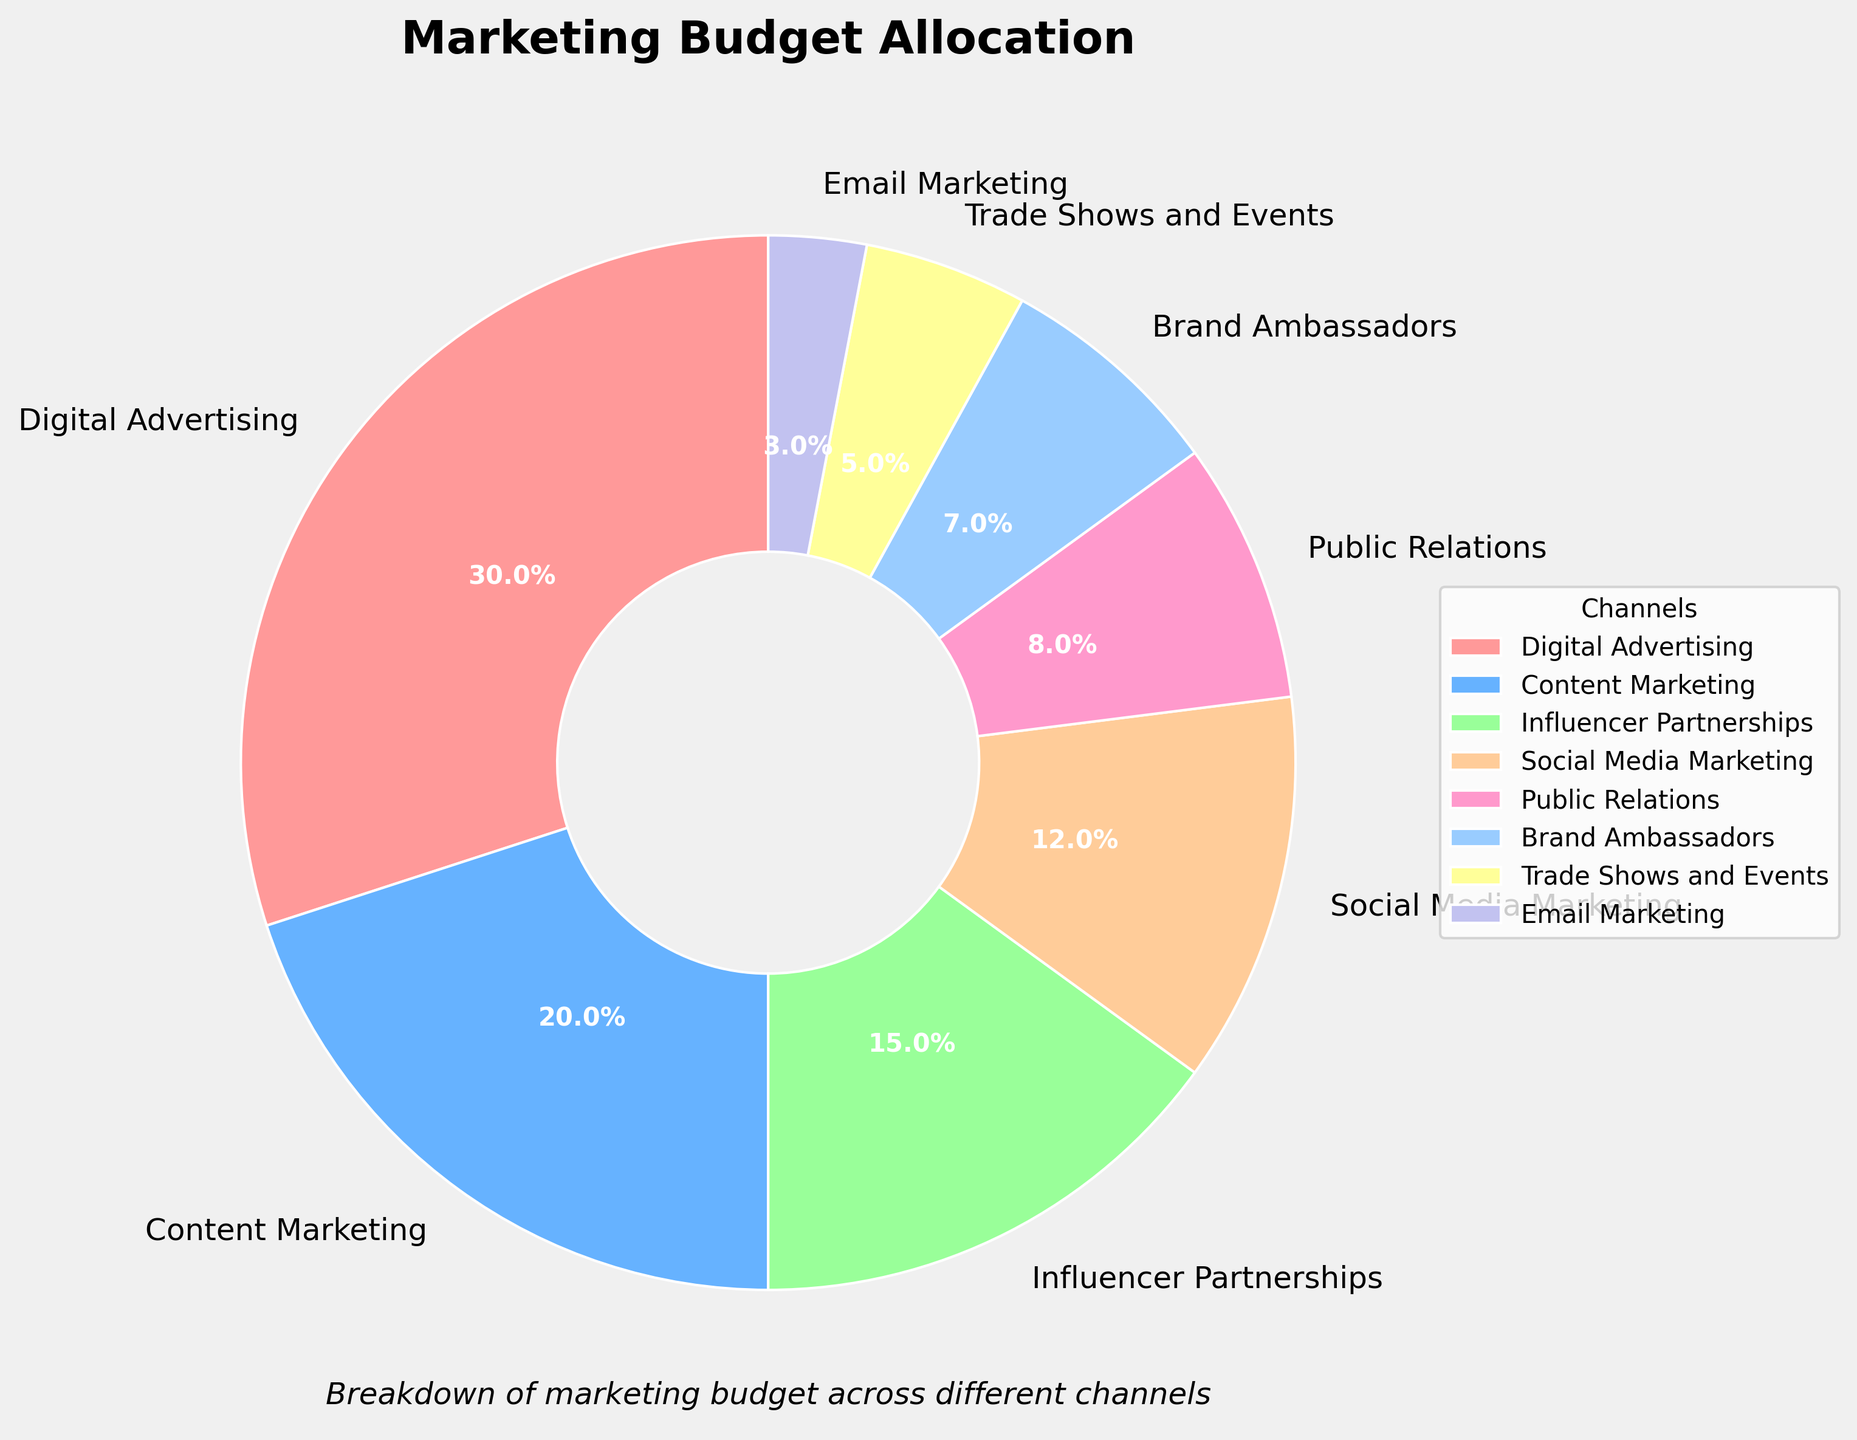What percentage of the budget is allocated to both Digital Advertising and Content Marketing combined? First, find the percentage of the budget for Digital Advertising (30%) and Content Marketing (20%). Then, add these two percentages together: 30% + 20% = 50%
Answer: 50% How much more of the budget is spent on Social Media Marketing compared to Email Marketing? Find the percentage for Social Media Marketing (12%) and Email Marketing (3%). Subtract the percentage for Email Marketing from Social Media Marketing: 12% - 3% = 9%
Answer: 9% Which marketing channel has the highest allocation? Look at the pie chart and identify the channel with the largest section. Digital Advertising, with 30%, is the largest.
Answer: Digital Advertising Is the percentage allocated to Public Relations greater than that allocated to Brand Ambassadors? Compare the percentage allocated to Public Relations (8%) with that allocated to Brand Ambassadors (7%). Since 8% > 7%, Public Relations has the higher allocation.
Answer: Yes What is the percentage difference between Trade Shows and Events, and Influencer Partnerships? Find the percentages for Trade Shows and Events (5%) and Influencer Partnerships (15%). Calculate the difference: 15% - 5% = 10%
Answer: 10% Which channels have less than 10% of the budget allocation? Identify the channels in the pie chart with slices representing less than 10%. These are Public Relations (8%), Brand Ambassadors (7%), Trade Shows and Events (5%), and Email Marketing (3%).
Answer: Public Relations, Brand Ambassadors, Trade Shows and Events, Email Marketing What is the second largest allocation in the marketing budget? Look at the pie chart and identify the second-largest section. Content Marketing, with 20%, is the second largest.
Answer: Content Marketing Does the combined budget for Trade Shows and Events, and Email Marketing exceed that of Influencer Partnerships? Find the budget for Trade Shows and Events (5%) and Email Marketing (3%) and sum them: 5% + 3% = 8%. Compare this to Influencer Partnerships’ budget of 15%. Since 8% < 15%, the combined budget does not exceed Influencer Partnerships.
Answer: No What is the color of the Digital Advertising slice in the pie chart? Locate the Digital Advertising slice in the pie chart. The color associated with it is the first one listed, which is red.
Answer: Red How much more is allocated to Content Marketing compared to Brand Ambassadors? Find the percentage for Content Marketing (20%) and Brand Ambassadors (7%). Subtract Brand Ambassadors’ percentage from Content Marketing's: 20% - 7% = 13%
Answer: 13% 